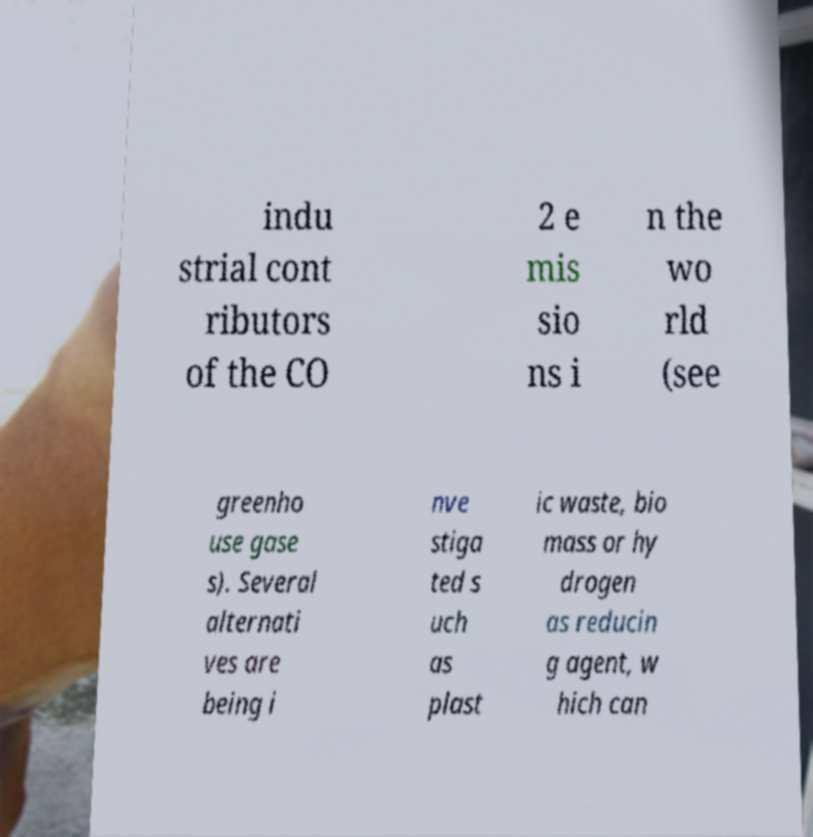Can you accurately transcribe the text from the provided image for me? indu strial cont ributors of the CO 2 e mis sio ns i n the wo rld (see greenho use gase s). Several alternati ves are being i nve stiga ted s uch as plast ic waste, bio mass or hy drogen as reducin g agent, w hich can 